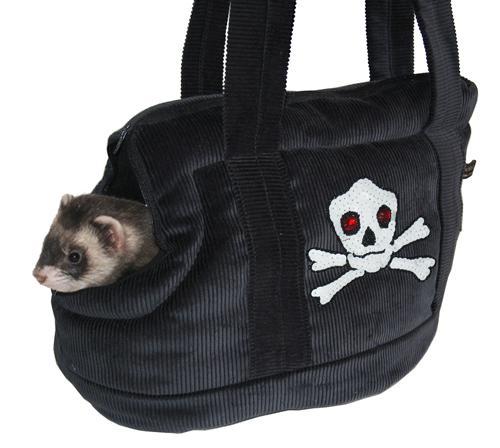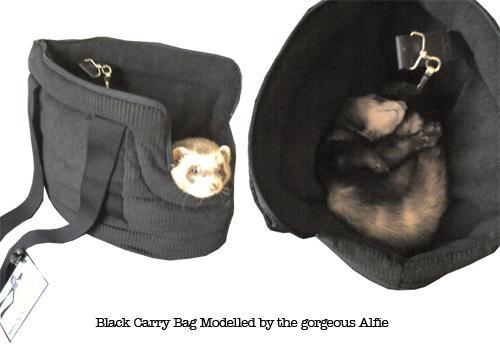The first image is the image on the left, the second image is the image on the right. Considering the images on both sides, is "There is a gray pouch with a brown inner lining containing a ferret." valid? Answer yes or no. No. 